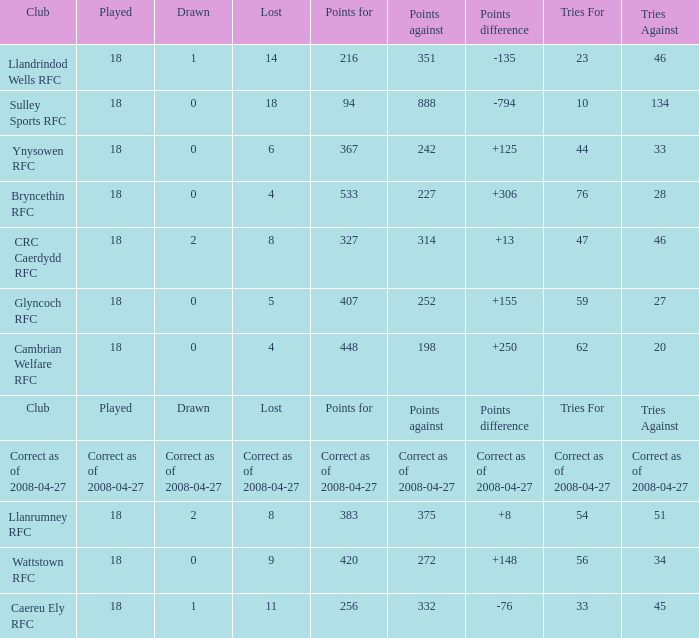What is the value for the item "Lost" when the value "Tries" is 47? 8.0. 